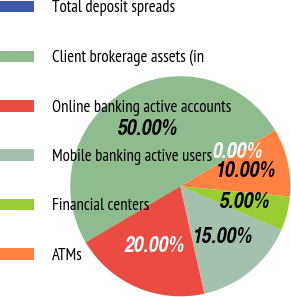<chart> <loc_0><loc_0><loc_500><loc_500><pie_chart><fcel>Total deposit spreads<fcel>Client brokerage assets (in<fcel>Online banking active accounts<fcel>Mobile banking active users<fcel>Financial centers<fcel>ATMs<nl><fcel>0.0%<fcel>50.0%<fcel>20.0%<fcel>15.0%<fcel>5.0%<fcel>10.0%<nl></chart> 